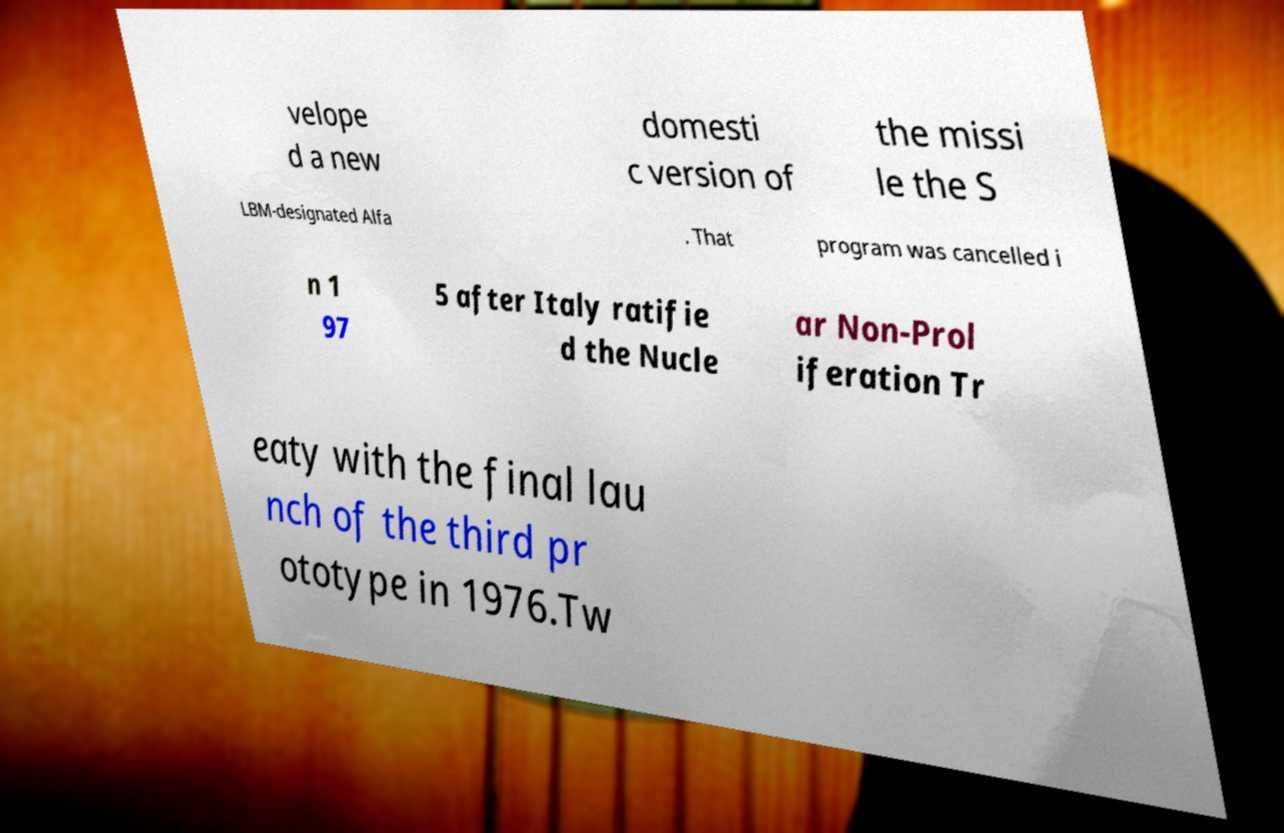Can you accurately transcribe the text from the provided image for me? velope d a new domesti c version of the missi le the S LBM-designated Alfa . That program was cancelled i n 1 97 5 after Italy ratifie d the Nucle ar Non-Prol iferation Tr eaty with the final lau nch of the third pr ototype in 1976.Tw 